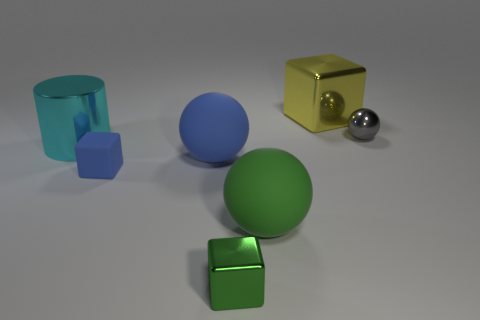Add 1 big blue shiny blocks. How many objects exist? 8 Subtract all cylinders. How many objects are left? 6 Subtract all big balls. Subtract all big cyan shiny cylinders. How many objects are left? 4 Add 6 large cyan shiny cylinders. How many large cyan shiny cylinders are left? 7 Add 5 gray matte objects. How many gray matte objects exist? 5 Subtract 0 yellow spheres. How many objects are left? 7 